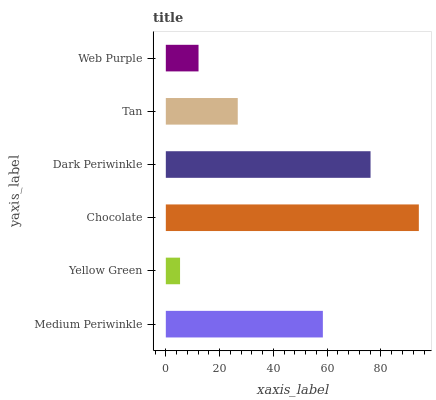Is Yellow Green the minimum?
Answer yes or no. Yes. Is Chocolate the maximum?
Answer yes or no. Yes. Is Chocolate the minimum?
Answer yes or no. No. Is Yellow Green the maximum?
Answer yes or no. No. Is Chocolate greater than Yellow Green?
Answer yes or no. Yes. Is Yellow Green less than Chocolate?
Answer yes or no. Yes. Is Yellow Green greater than Chocolate?
Answer yes or no. No. Is Chocolate less than Yellow Green?
Answer yes or no. No. Is Medium Periwinkle the high median?
Answer yes or no. Yes. Is Tan the low median?
Answer yes or no. Yes. Is Chocolate the high median?
Answer yes or no. No. Is Chocolate the low median?
Answer yes or no. No. 